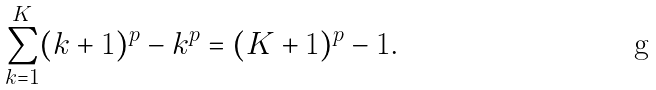Convert formula to latex. <formula><loc_0><loc_0><loc_500><loc_500>\sum _ { k = 1 } ^ { K } ( k + 1 ) ^ { p } - k ^ { p } = ( K + 1 ) ^ { p } - 1 .</formula> 